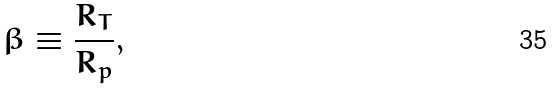Convert formula to latex. <formula><loc_0><loc_0><loc_500><loc_500>\beta \equiv \frac { R _ { T } } { R _ { p } } ,</formula> 